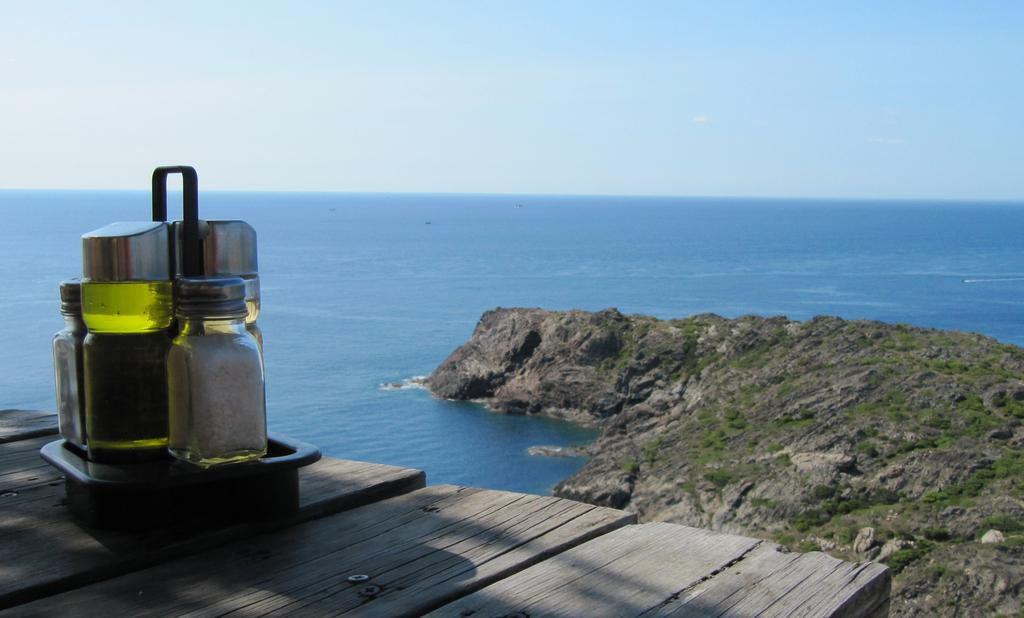What objects are on the table in the image? There are bottles on a table in the image. What can be seen in the sky near the table? The clear sky is visible near the table. What type of pencil can be seen being used by the cattle in the image? There are no cattle or pencils present in the image. What type of building is visible in the background of the image? There is no building visible in the image; it only features bottles on a table and the clear sky. 